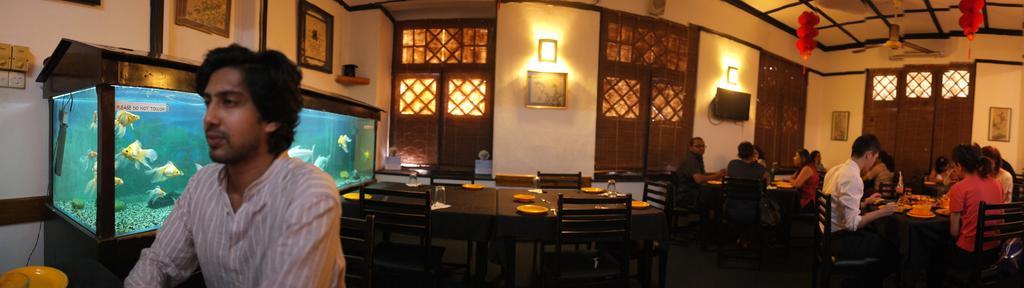Could you give a brief overview of what you see in this image? The picture is clicked inside a restaurant where many people are eating on the table. There are few tables which are unoccupied. There is an aquarium to the left of the image. 